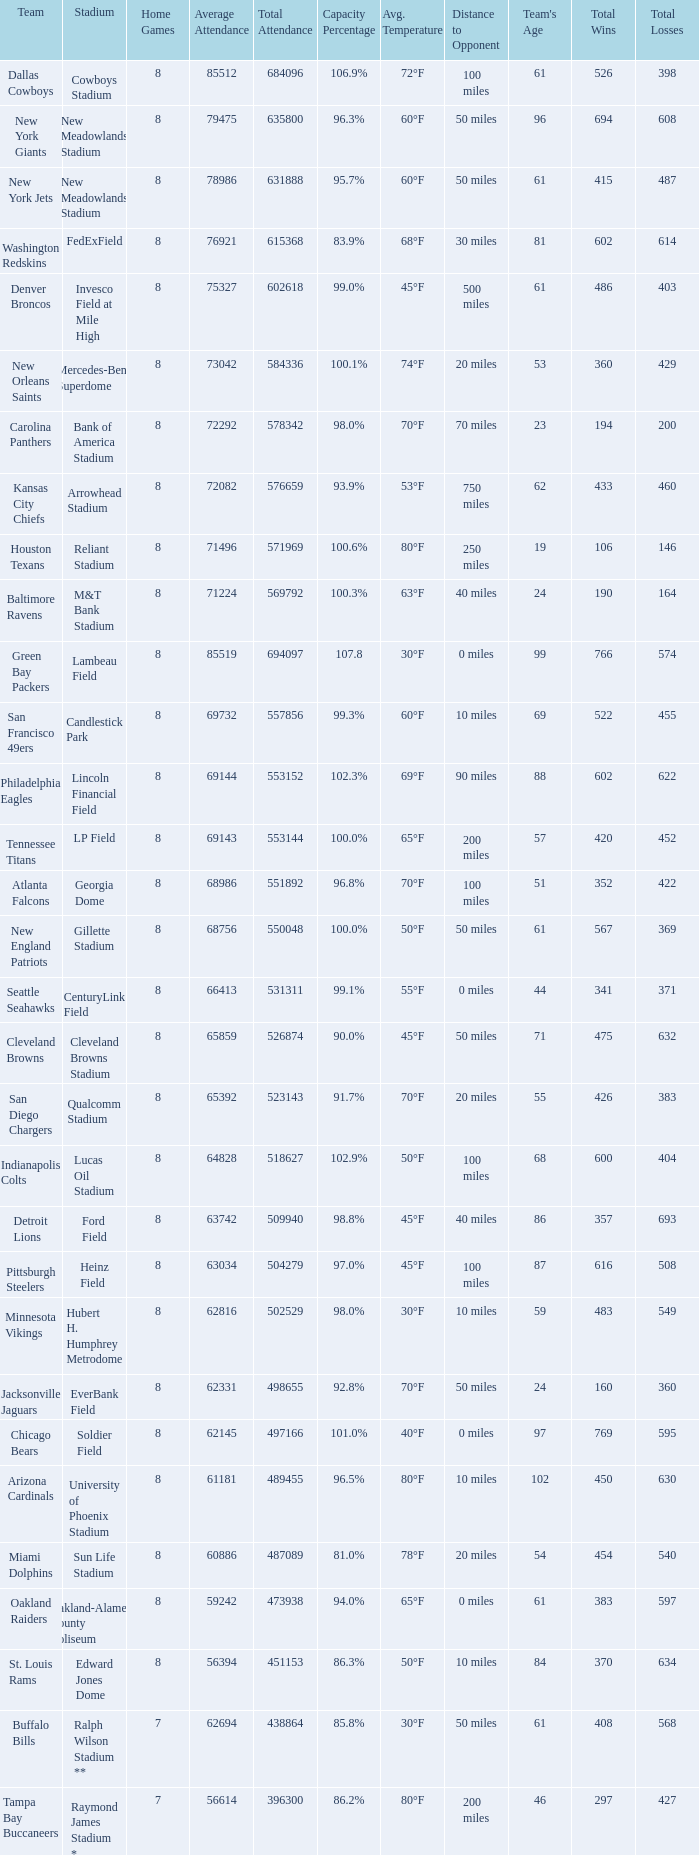What is the name of the stadium when the capacity percentage is 83.9% FedExField. 